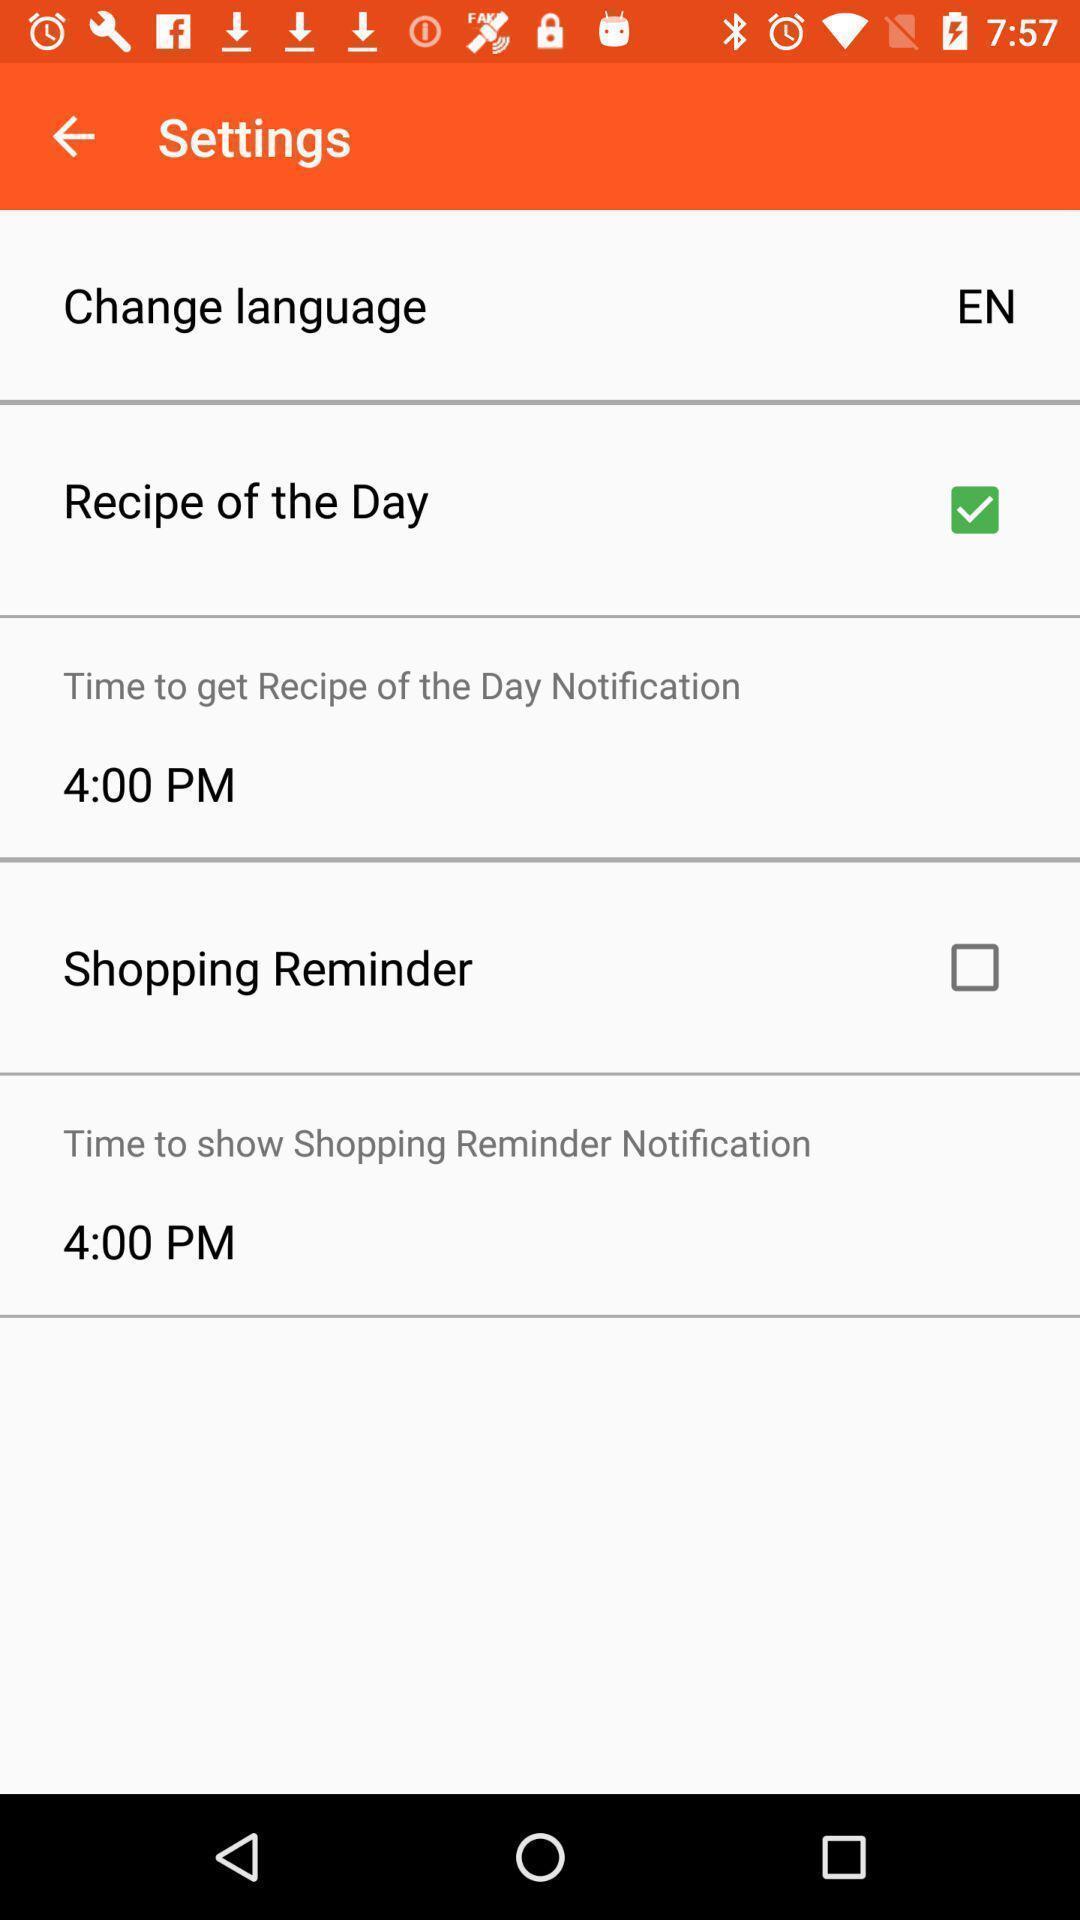Give me a narrative description of this picture. Settings page. 